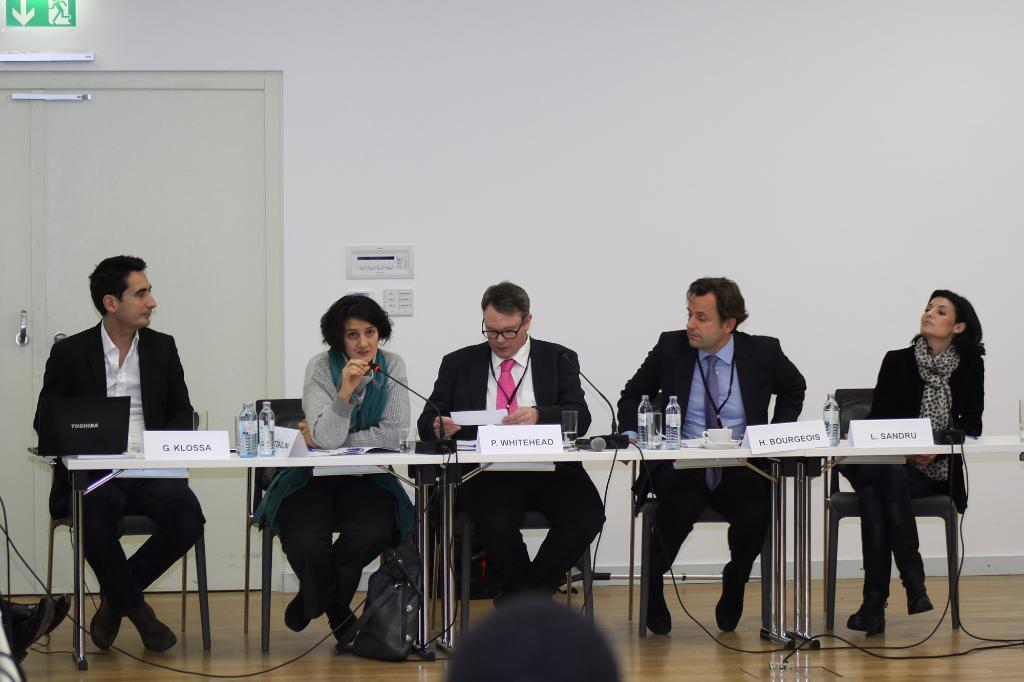Can you describe this image briefly? In this image I can see in the middle a woman is sitting on the chair and speaking into microphone. Beside her few people are sitting, they are wearing black color coats. In the middle there are water bottles on this table. On the left side there's the door. 